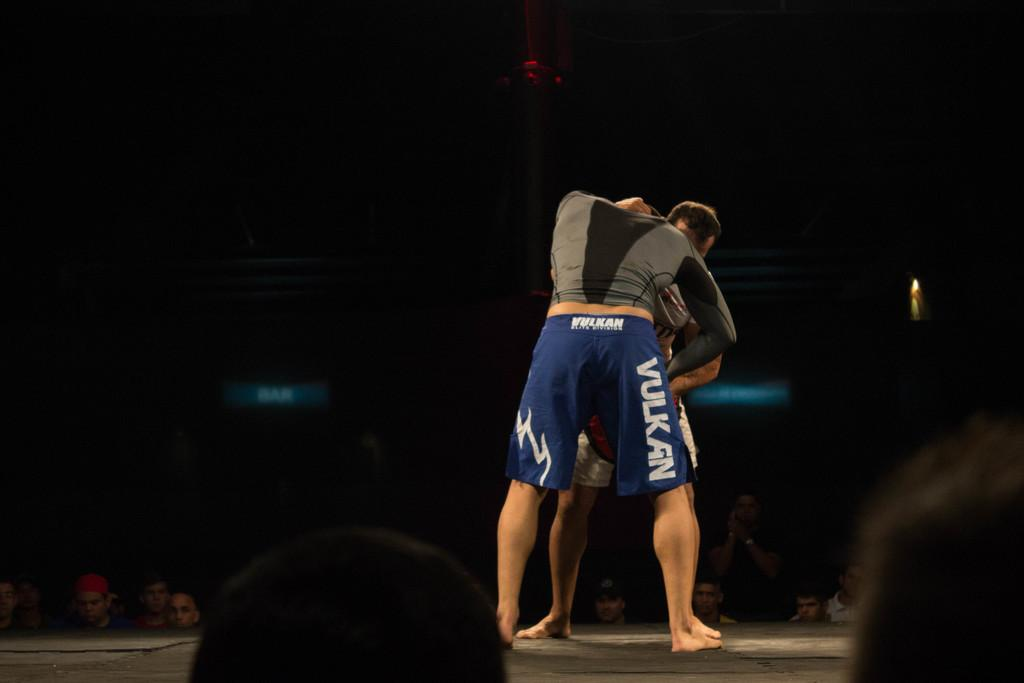<image>
Present a compact description of the photo's key features. A man in blue, boxing shorts that say Vulkan on the side is trying to pin another man in front of him, while standing. 